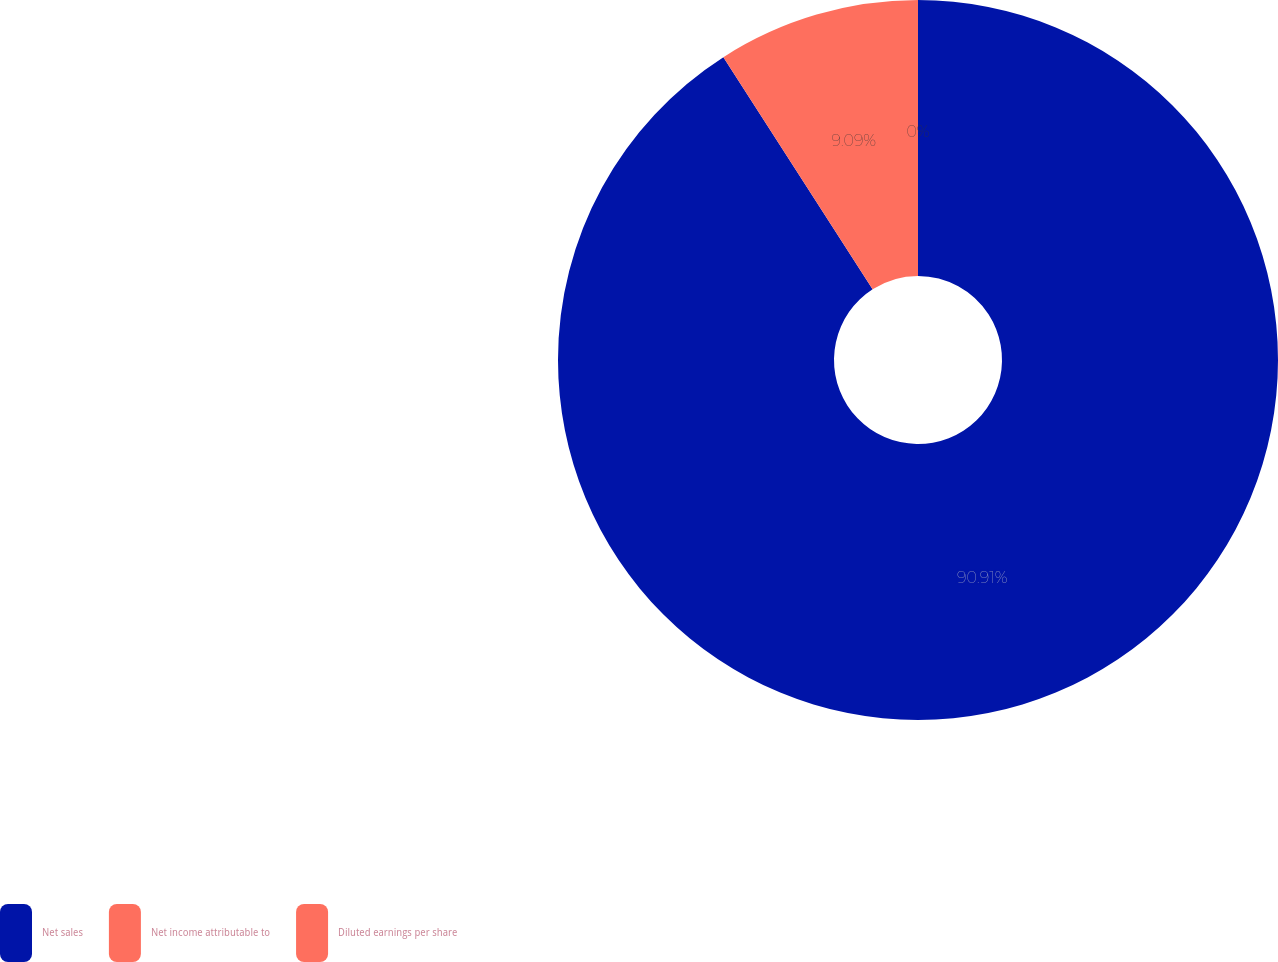<chart> <loc_0><loc_0><loc_500><loc_500><pie_chart><fcel>Net sales<fcel>Net income attributable to<fcel>Diluted earnings per share<nl><fcel>90.91%<fcel>9.09%<fcel>0.0%<nl></chart> 